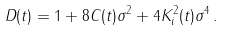Convert formula to latex. <formula><loc_0><loc_0><loc_500><loc_500>D ( t ) = 1 + 8 C ( t ) \sigma ^ { 2 } + 4 K _ { i } ^ { 2 } ( t ) \sigma ^ { 4 } \, .</formula> 